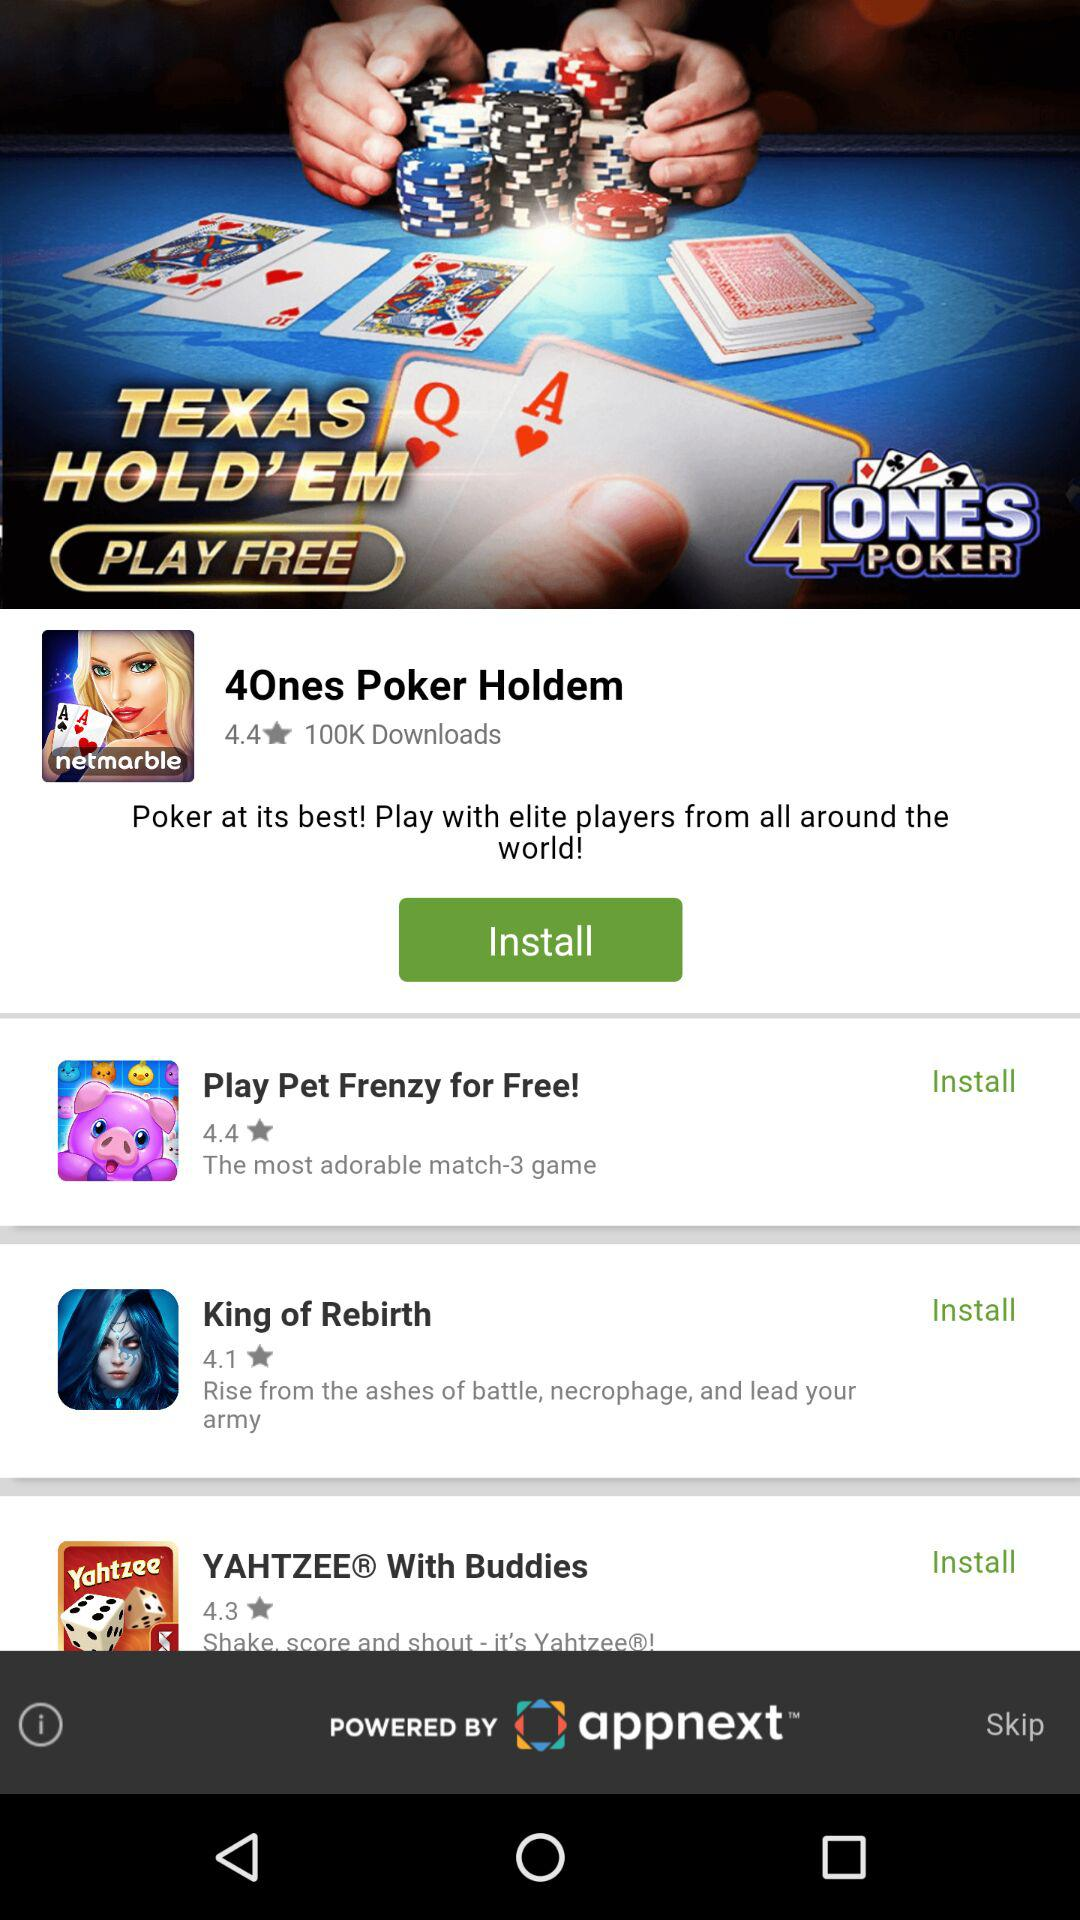What is the rating for "4Ones Poker Holdem"? The rating is 4.4. 